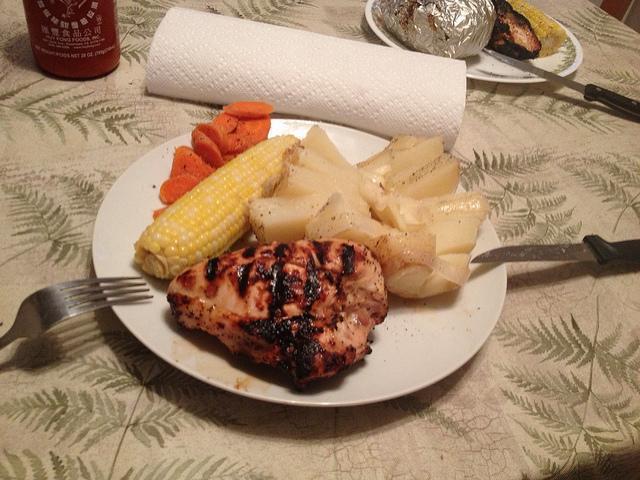How many different types of vegetables are on the plate?
Give a very brief answer. 3. 